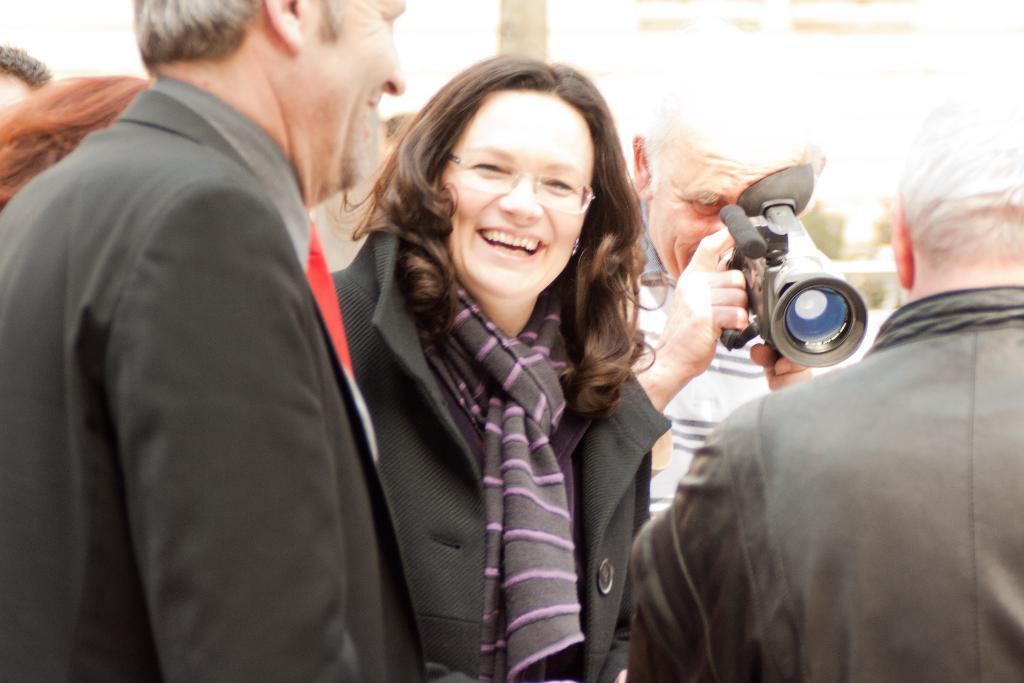Could you give a brief overview of what you see in this image? In this picture this woman is highlighted, she wore spectacles and scarf. Beside this woman there is a man is standing in a suit. Backside of this woman a person is standing and he is holding a camera. 